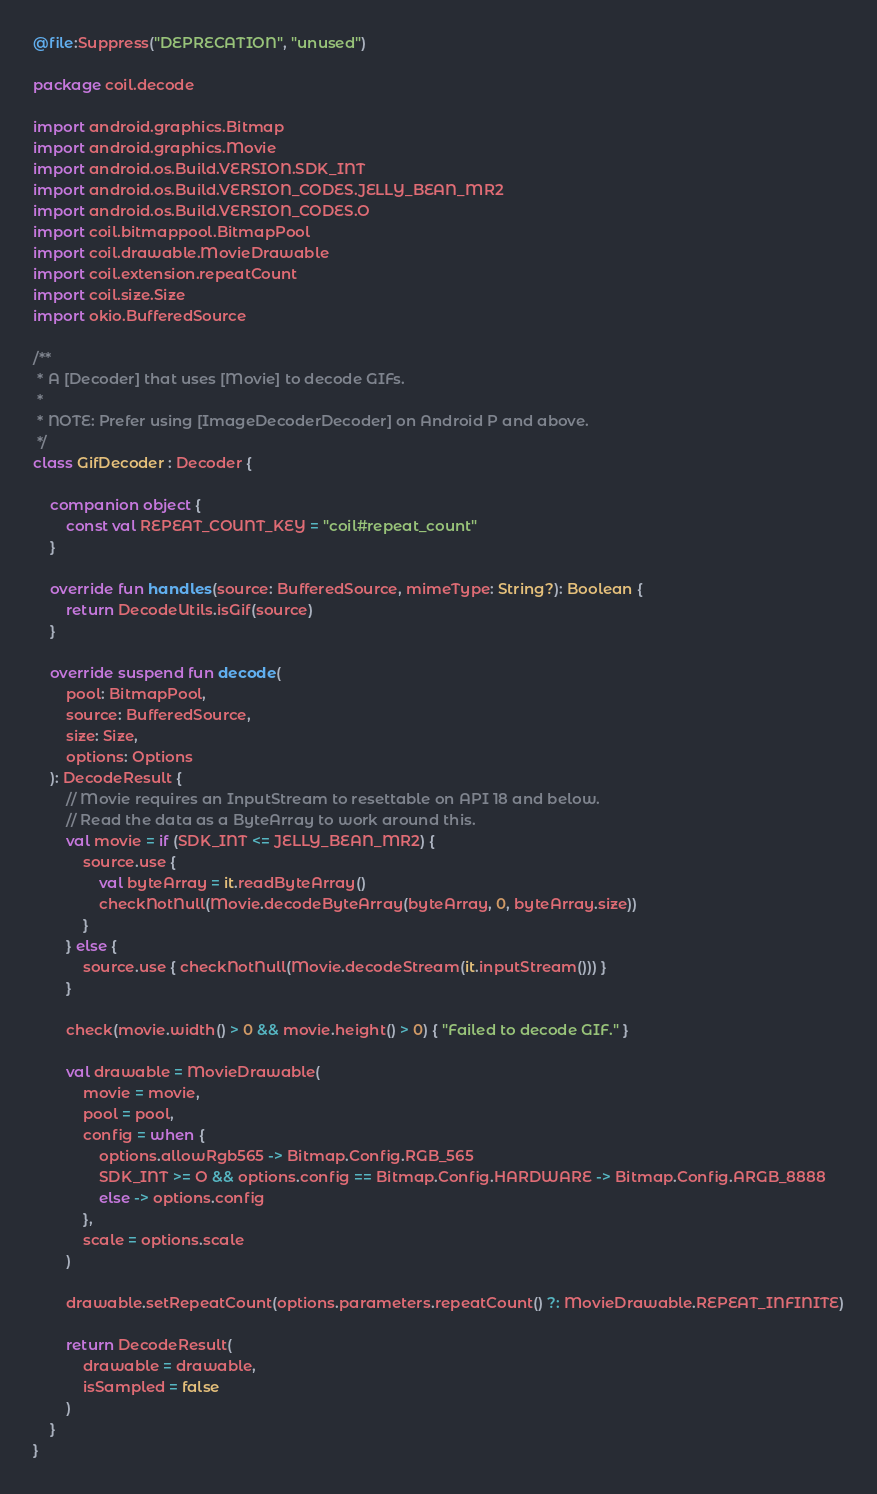<code> <loc_0><loc_0><loc_500><loc_500><_Kotlin_>@file:Suppress("DEPRECATION", "unused")

package coil.decode

import android.graphics.Bitmap
import android.graphics.Movie
import android.os.Build.VERSION.SDK_INT
import android.os.Build.VERSION_CODES.JELLY_BEAN_MR2
import android.os.Build.VERSION_CODES.O
import coil.bitmappool.BitmapPool
import coil.drawable.MovieDrawable
import coil.extension.repeatCount
import coil.size.Size
import okio.BufferedSource

/**
 * A [Decoder] that uses [Movie] to decode GIFs.
 *
 * NOTE: Prefer using [ImageDecoderDecoder] on Android P and above.
 */
class GifDecoder : Decoder {

    companion object {
        const val REPEAT_COUNT_KEY = "coil#repeat_count"
    }

    override fun handles(source: BufferedSource, mimeType: String?): Boolean {
        return DecodeUtils.isGif(source)
    }

    override suspend fun decode(
        pool: BitmapPool,
        source: BufferedSource,
        size: Size,
        options: Options
    ): DecodeResult {
        // Movie requires an InputStream to resettable on API 18 and below.
        // Read the data as a ByteArray to work around this.
        val movie = if (SDK_INT <= JELLY_BEAN_MR2) {
            source.use {
                val byteArray = it.readByteArray()
                checkNotNull(Movie.decodeByteArray(byteArray, 0, byteArray.size))
            }
        } else {
            source.use { checkNotNull(Movie.decodeStream(it.inputStream())) }
        }

        check(movie.width() > 0 && movie.height() > 0) { "Failed to decode GIF." }

        val drawable = MovieDrawable(
            movie = movie,
            pool = pool,
            config = when {
                options.allowRgb565 -> Bitmap.Config.RGB_565
                SDK_INT >= O && options.config == Bitmap.Config.HARDWARE -> Bitmap.Config.ARGB_8888
                else -> options.config
            },
            scale = options.scale
        )

        drawable.setRepeatCount(options.parameters.repeatCount() ?: MovieDrawable.REPEAT_INFINITE)

        return DecodeResult(
            drawable = drawable,
            isSampled = false
        )
    }
}
</code> 